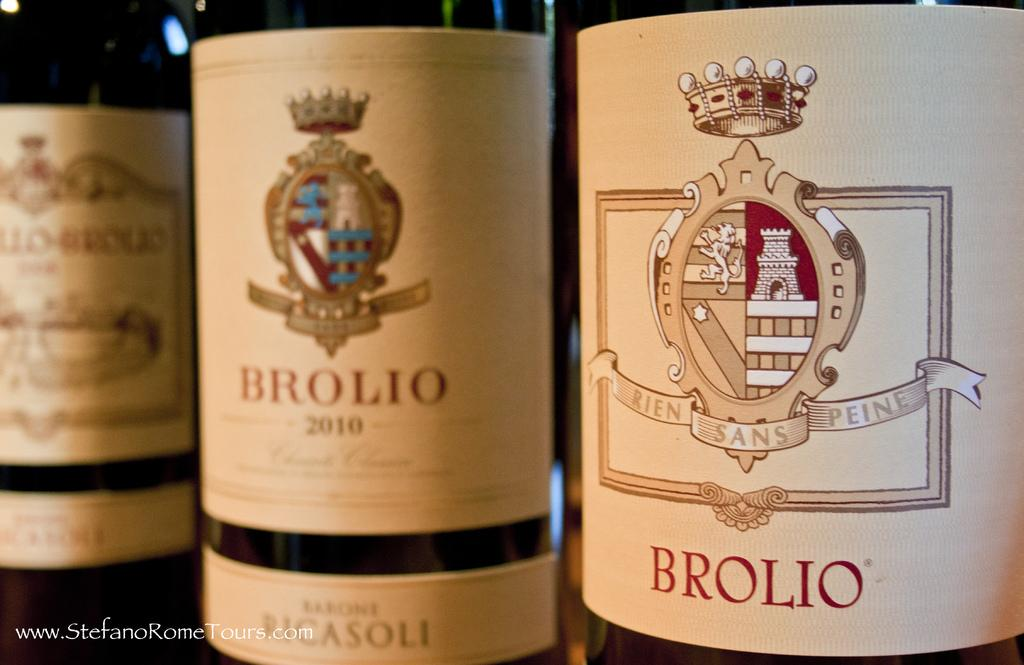<image>
Provide a brief description of the given image. three slightly different bottles of brolio next to each other 